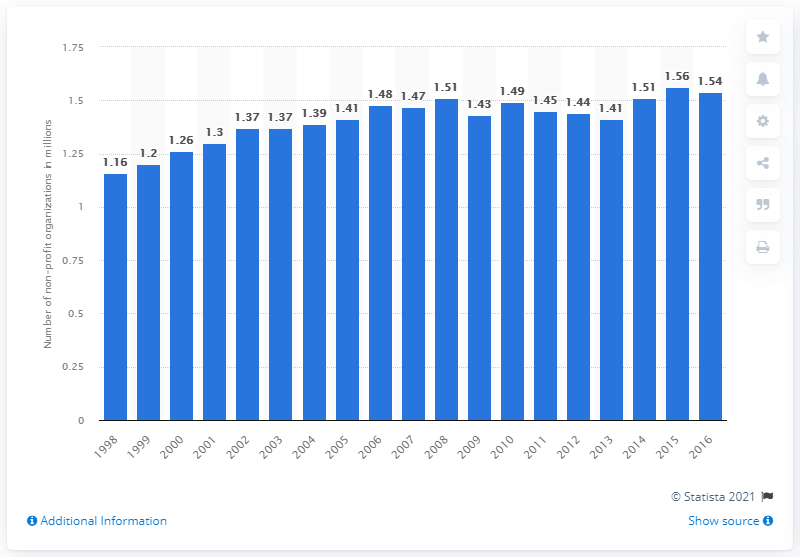Highlight a few significant elements in this photo. In 2016, there were 1.54 registered non-profit organizations with the Internal Revenue Service. 